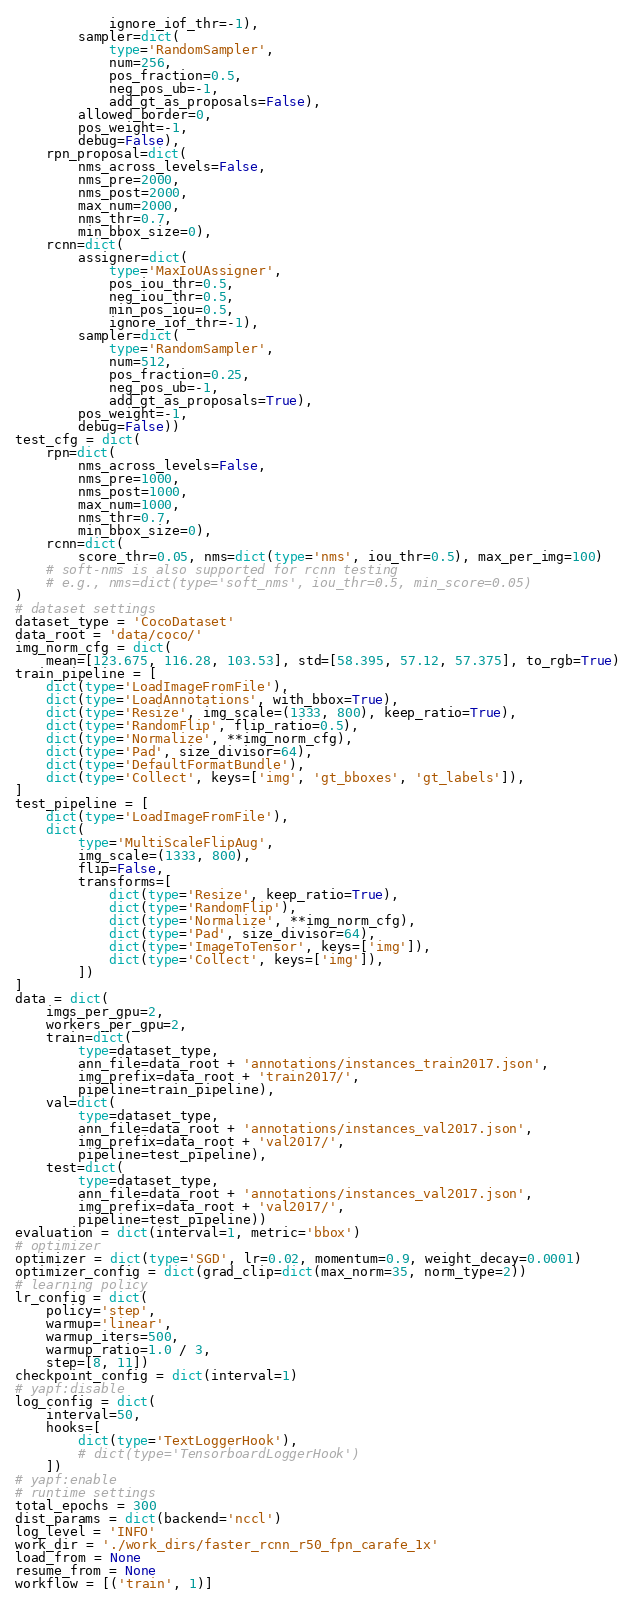Convert code to text. <code><loc_0><loc_0><loc_500><loc_500><_Python_>            ignore_iof_thr=-1),
        sampler=dict(
            type='RandomSampler',
            num=256,
            pos_fraction=0.5,
            neg_pos_ub=-1,
            add_gt_as_proposals=False),
        allowed_border=0,
        pos_weight=-1,
        debug=False),
    rpn_proposal=dict(
        nms_across_levels=False,
        nms_pre=2000,
        nms_post=2000,
        max_num=2000,
        nms_thr=0.7,
        min_bbox_size=0),
    rcnn=dict(
        assigner=dict(
            type='MaxIoUAssigner',
            pos_iou_thr=0.5,
            neg_iou_thr=0.5,
            min_pos_iou=0.5,
            ignore_iof_thr=-1),
        sampler=dict(
            type='RandomSampler',
            num=512,
            pos_fraction=0.25,
            neg_pos_ub=-1,
            add_gt_as_proposals=True),
        pos_weight=-1,
        debug=False))
test_cfg = dict(
    rpn=dict(
        nms_across_levels=False,
        nms_pre=1000,
        nms_post=1000,
        max_num=1000,
        nms_thr=0.7,
        min_bbox_size=0),
    rcnn=dict(
        score_thr=0.05, nms=dict(type='nms', iou_thr=0.5), max_per_img=100)
    # soft-nms is also supported for rcnn testing
    # e.g., nms=dict(type='soft_nms', iou_thr=0.5, min_score=0.05)
)
# dataset settings
dataset_type = 'CocoDataset'
data_root = 'data/coco/'
img_norm_cfg = dict(
    mean=[123.675, 116.28, 103.53], std=[58.395, 57.12, 57.375], to_rgb=True)
train_pipeline = [
    dict(type='LoadImageFromFile'),
    dict(type='LoadAnnotations', with_bbox=True),
    dict(type='Resize', img_scale=(1333, 800), keep_ratio=True),
    dict(type='RandomFlip', flip_ratio=0.5),
    dict(type='Normalize', **img_norm_cfg),
    dict(type='Pad', size_divisor=64),
    dict(type='DefaultFormatBundle'),
    dict(type='Collect', keys=['img', 'gt_bboxes', 'gt_labels']),
]
test_pipeline = [
    dict(type='LoadImageFromFile'),
    dict(
        type='MultiScaleFlipAug',
        img_scale=(1333, 800),
        flip=False,
        transforms=[
            dict(type='Resize', keep_ratio=True),
            dict(type='RandomFlip'),
            dict(type='Normalize', **img_norm_cfg),
            dict(type='Pad', size_divisor=64),
            dict(type='ImageToTensor', keys=['img']),
            dict(type='Collect', keys=['img']),
        ])
]
data = dict(
    imgs_per_gpu=2,
    workers_per_gpu=2,
    train=dict(
        type=dataset_type,
        ann_file=data_root + 'annotations/instances_train2017.json',
        img_prefix=data_root + 'train2017/',
        pipeline=train_pipeline),
    val=dict(
        type=dataset_type,
        ann_file=data_root + 'annotations/instances_val2017.json',
        img_prefix=data_root + 'val2017/',
        pipeline=test_pipeline),
    test=dict(
        type=dataset_type,
        ann_file=data_root + 'annotations/instances_val2017.json',
        img_prefix=data_root + 'val2017/',
        pipeline=test_pipeline))
evaluation = dict(interval=1, metric='bbox')
# optimizer
optimizer = dict(type='SGD', lr=0.02, momentum=0.9, weight_decay=0.0001)
optimizer_config = dict(grad_clip=dict(max_norm=35, norm_type=2))
# learning policy
lr_config = dict(
    policy='step',
    warmup='linear',
    warmup_iters=500,
    warmup_ratio=1.0 / 3,
    step=[8, 11])
checkpoint_config = dict(interval=1)
# yapf:disable
log_config = dict(
    interval=50,
    hooks=[
        dict(type='TextLoggerHook'),
        # dict(type='TensorboardLoggerHook')
    ])
# yapf:enable
# runtime settings
total_epochs = 300
dist_params = dict(backend='nccl')
log_level = 'INFO'
work_dir = './work_dirs/faster_rcnn_r50_fpn_carafe_1x'
load_from = None
resume_from = None
workflow = [('train', 1)]
</code> 